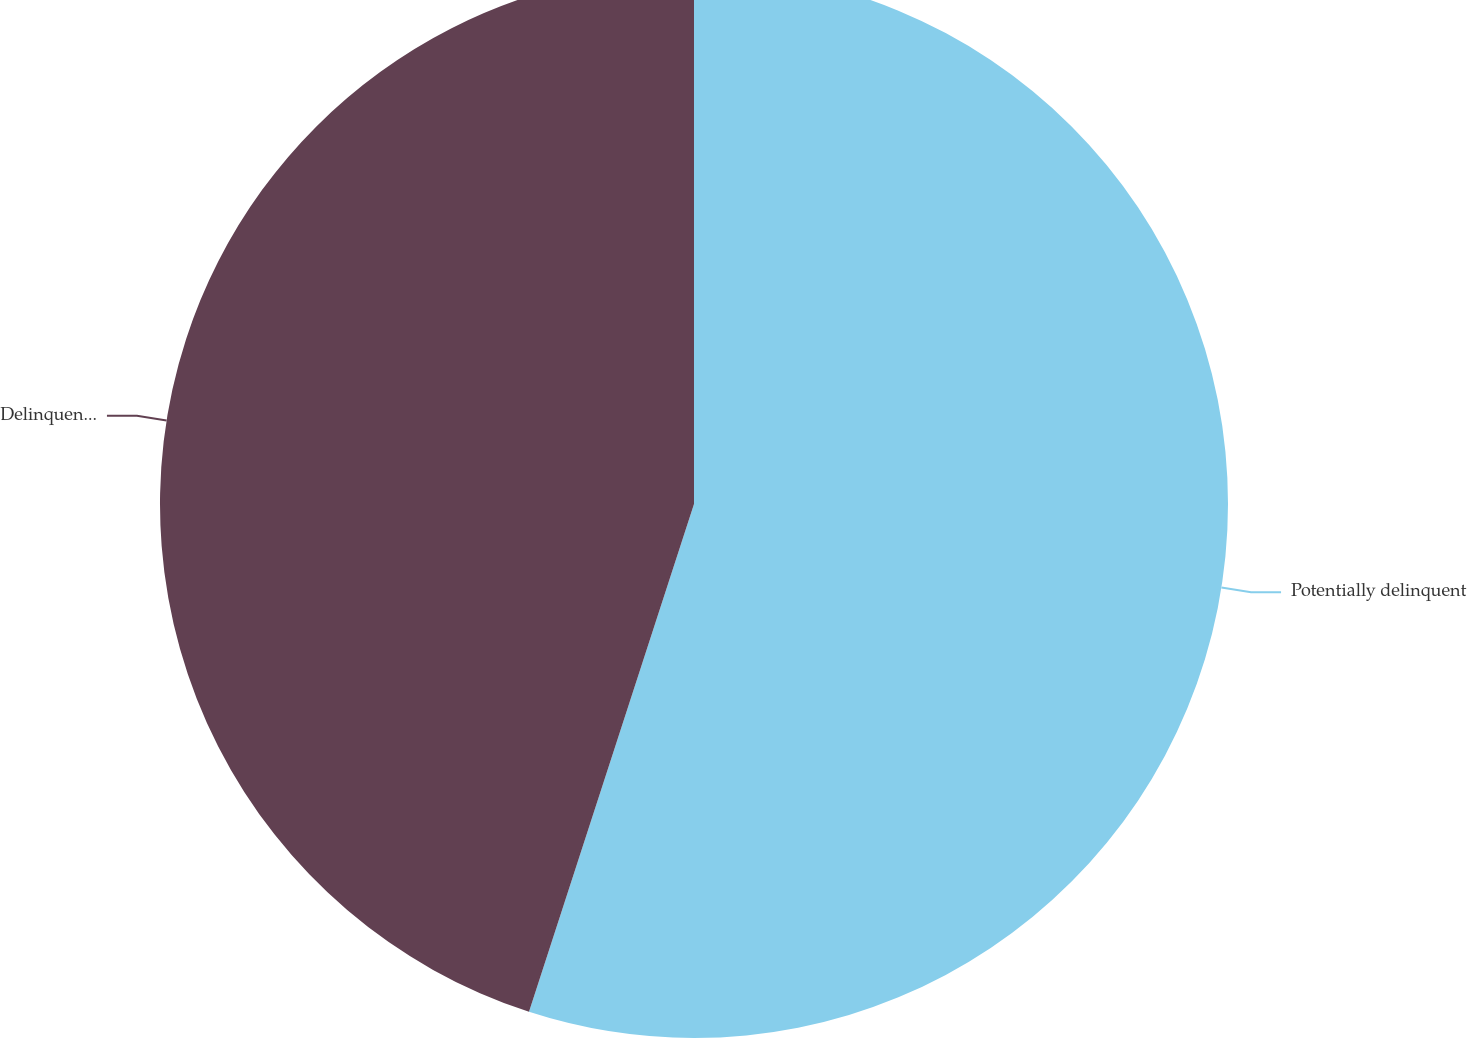Convert chart. <chart><loc_0><loc_0><loc_500><loc_500><pie_chart><fcel>Potentially delinquent<fcel>Delinquent or under<nl><fcel>55.0%<fcel>45.0%<nl></chart> 